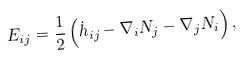Convert formula to latex. <formula><loc_0><loc_0><loc_500><loc_500>E _ { i j } = \frac { 1 } { 2 } \left ( \dot { h } _ { i j } - \nabla _ { i } N _ { j } - \nabla _ { j } N _ { i } \right ) ,</formula> 